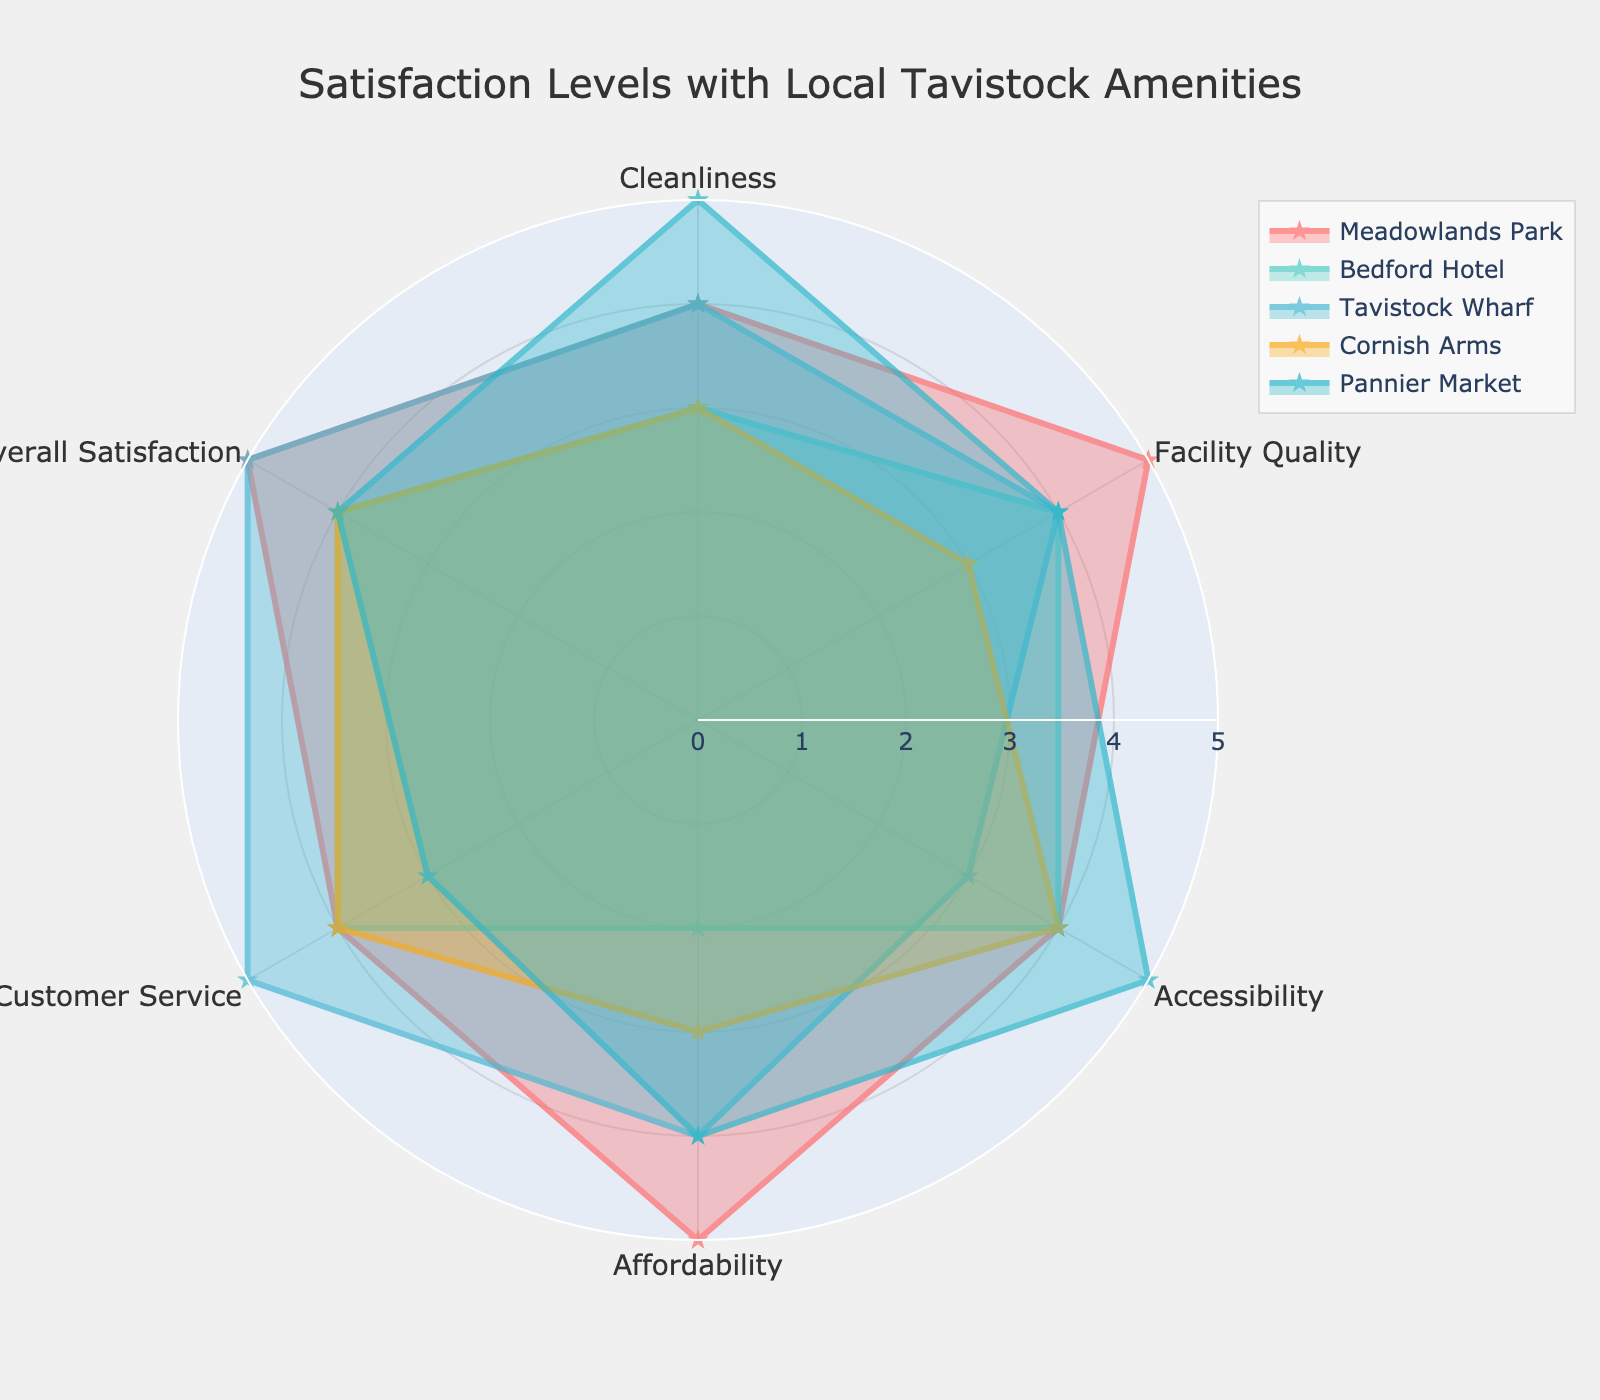What is the title of the radar chart? Look at the top center of the radar chart where the title is positioned.
Answer: Satisfaction Levels with Local Tavistock Amenities Which amenity has the highest rating for Cleanliness? Look at the Cleanliness axis and identify which amenity has the highest value. Meadowlands Park and Tavistock Wharf both have a rating of 4.
Answer: Meadowlands Park, Tavistock Wharf Which category has the lowest satisfaction rating for Bedford Hotel? Find the line representing Bedford Hotel and look for the lowest point on the radar chart. Bedfrod Hotel has a rating of 2 in Affordability.
Answer: Affordability How does the Overall Satisfaction of Cornish Arms compare to that of Pannier Market? Locate the Overall Satisfaction values for both Cornish Arms and Pannier Market, and compare them. Cornish Arms has an Overall Satisfaction of 4, while Pannier Market also has a rating of 4.
Answer: Equal What is the average Facility Quality rating across all amenities? Add the Facility Quality ratings for all amenities and divide by the number of amenities: (5+4+4+3+4)/5. The sum is 20, so the average is 20/5.
Answer: 4 Which categories have consistently high ratings (4 or 5) across all amenities? Check each category to see if all their ratings are 4 or 5. Facility Quality and Overall Satisfaction meet this criterion.
Answer: Facility Quality, Overall Satisfaction What rating does Tavistock Wharf have for Customer Service? Find Tavistock Wharf's rating on the Customer Service axis. Tavistock Wharf has a rating of 5.
Answer: 5 Which amenity has the most balanced ratings across all categories? Compare the ratings of each amenity and see which one fluctuates the least. Pannier Market has relatively even ratings of 5, 4, 5, 4, 3, and 4.
Answer: Pannier Market How does Affordability rating of Bedford Hotel compare to the other amenities? Look at Bedford Hotel's rating for Affordability and compare it to the others. Bedford Hotel's Affordability rating is 2, which is lower than the others, which are 5, 4, 3, and 4.
Answer: Lower What are the top two categories for Meadowlands Park based on satisfaction ratings? Identify Meadowlands Park's highest ratings across the categories. Meadowlands Park has ratings of 5 in Facility Quality and Overall Satisfaction.
Answer: Facility Quality, Overall Satisfaction 